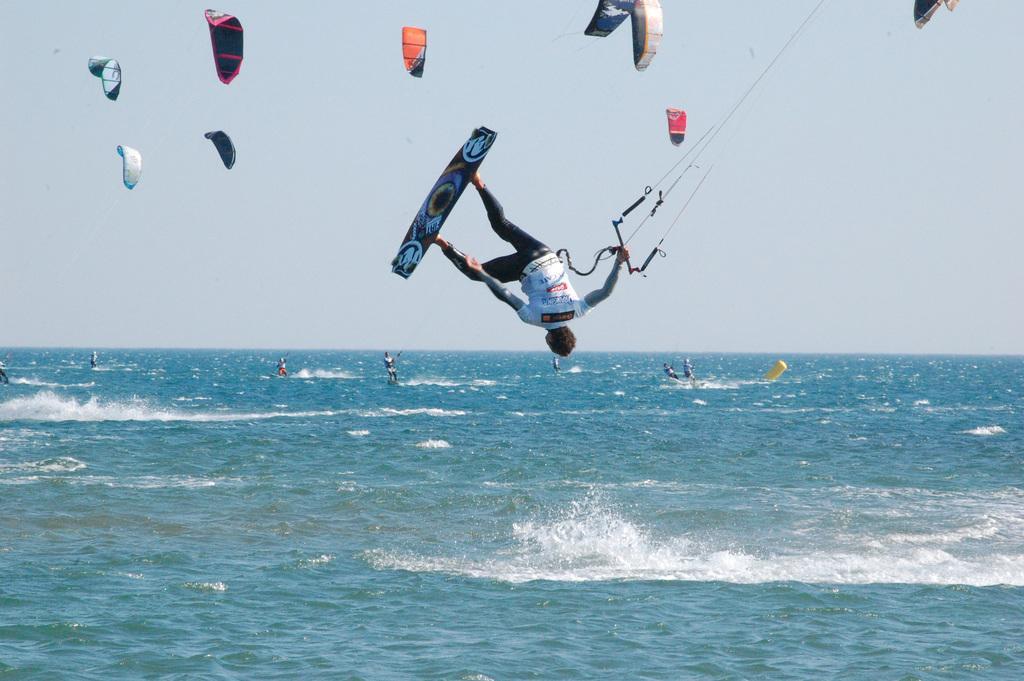Please provide a concise description of this image. In the center of the image we can see a man jumping with surfing board and holding a rope. At the bottom there is a sea and we can see people surfing in the sea. At the top there are parachutes and sky. 